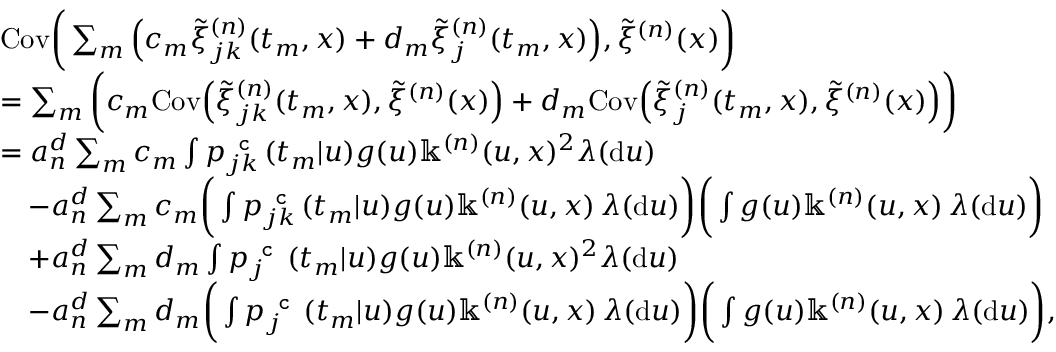<formula> <loc_0><loc_0><loc_500><loc_500>\begin{array} { r l } & { C o v \left ( \sum _ { m } \left ( c _ { m } \tilde { \xi } _ { j k } ^ { ( n ) } ( t _ { m } , x ) + d _ { m } \tilde { \xi } _ { j } ^ { ( n ) } ( t _ { m } , x ) \right ) , \tilde { \xi } ^ { ( n ) } ( x ) \right ) } \\ & { = \sum _ { m } \left ( c _ { m } C o v \left ( \tilde { \xi } _ { j k } ^ { ( n ) } ( t _ { m } , x ) , \tilde { \xi } ^ { ( n ) } ( x ) \right ) + d _ { m } C o v \left ( \tilde { \xi } _ { j } ^ { ( n ) } ( t _ { m } , x ) , \tilde { \xi } ^ { ( n ) } ( x ) \right ) \right ) } \\ & { = a _ { n } ^ { d } \sum _ { m } c _ { m } \int p _ { j k } ^ { c } ( t _ { m } | u ) g ( u ) \mathbb { k } ^ { ( n ) } ( u , x ) ^ { 2 } \lambda ( d u ) } \\ & { \quad - a _ { n } ^ { d } \sum _ { m } c _ { m } \left ( \int p _ { j k } ^ { c } ( t _ { m } | u ) g ( u ) \mathbb { k } ^ { ( n ) } ( u , x ) \, \lambda ( d u ) \right ) \left ( \int g ( u ) \mathbb { k } ^ { ( n ) } ( u , x ) \, \lambda ( d u ) \right ) } \\ & { \quad + a _ { n } ^ { d } \sum _ { m } d _ { m } \int p _ { j } ^ { c } ( t _ { m } | u ) g ( u ) \mathbb { k } ^ { ( n ) } ( u , x ) ^ { 2 } \lambda ( d u ) } \\ & { \quad - a _ { n } ^ { d } \sum _ { m } d _ { m } \left ( \int p _ { j } ^ { c } ( t _ { m } | u ) g ( u ) \mathbb { k } ^ { ( n ) } ( u , x ) \, \lambda ( d u ) \right ) \left ( \int g ( u ) \mathbb { k } ^ { ( n ) } ( u , x ) \, \lambda ( d u ) \right ) , } \end{array}</formula> 